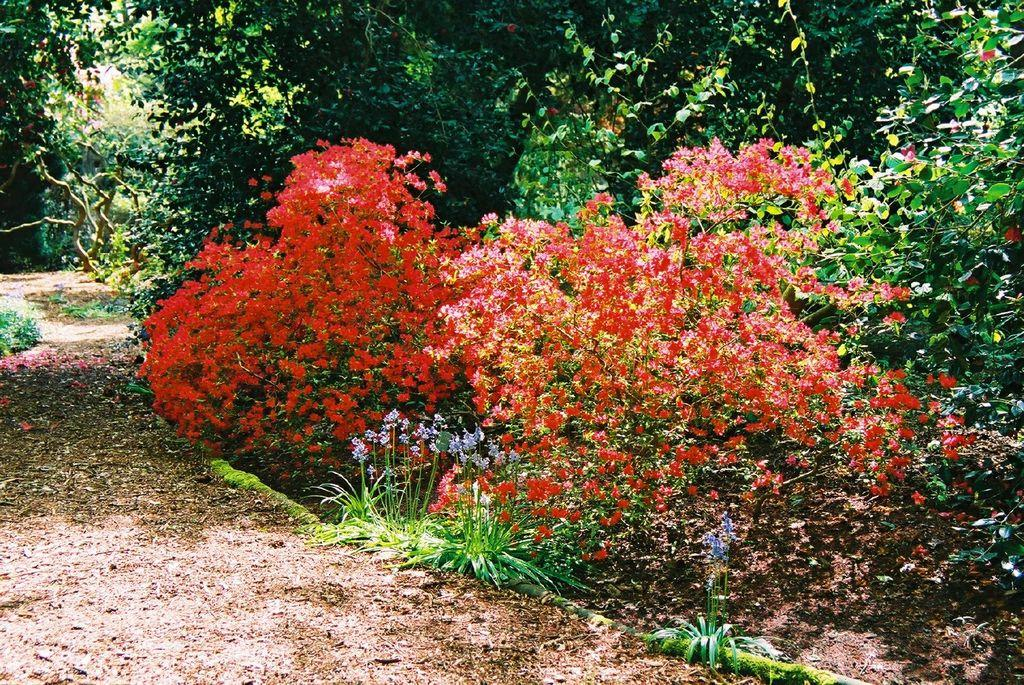Where was the image taken? The image was clicked outside. What can be seen in the middle of the image? There are bushes in the middle of the image. What is visible at the top of the image? There are trees at the top of the image. What type of flowers can be seen in the image? There are red and blue flowers in the image. What type of lipstick is being used on the pie in the image? There is no pie or lipstick present in the image. Can you tell me how many crackers are visible in the image? There are no crackers present in the image. 